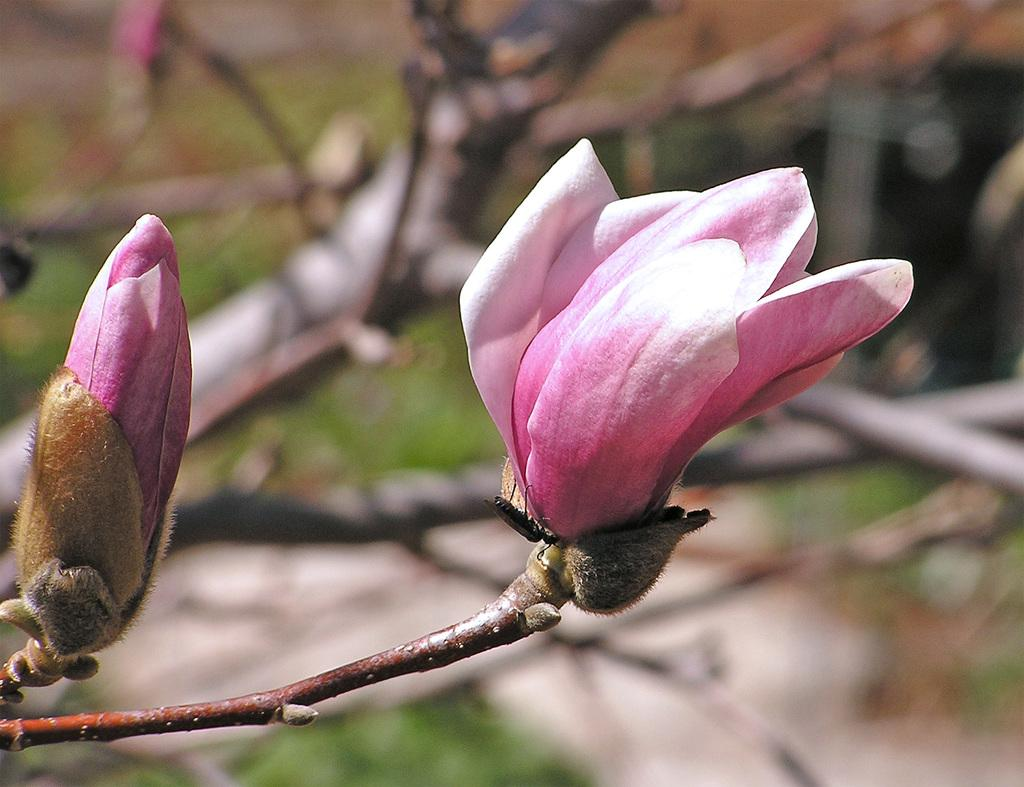What is the main subject of the image? There is a flower in the image. Can you describe the flower's current state? The flower has a bud. What other living organism can be seen in the image? There is an insect in the image. What can be seen in the background of the image? There are plants in the background of the image. How does the flower contribute to the pencil's growth in the image? There is no pencil present in the image, so it cannot contribute to its growth. 